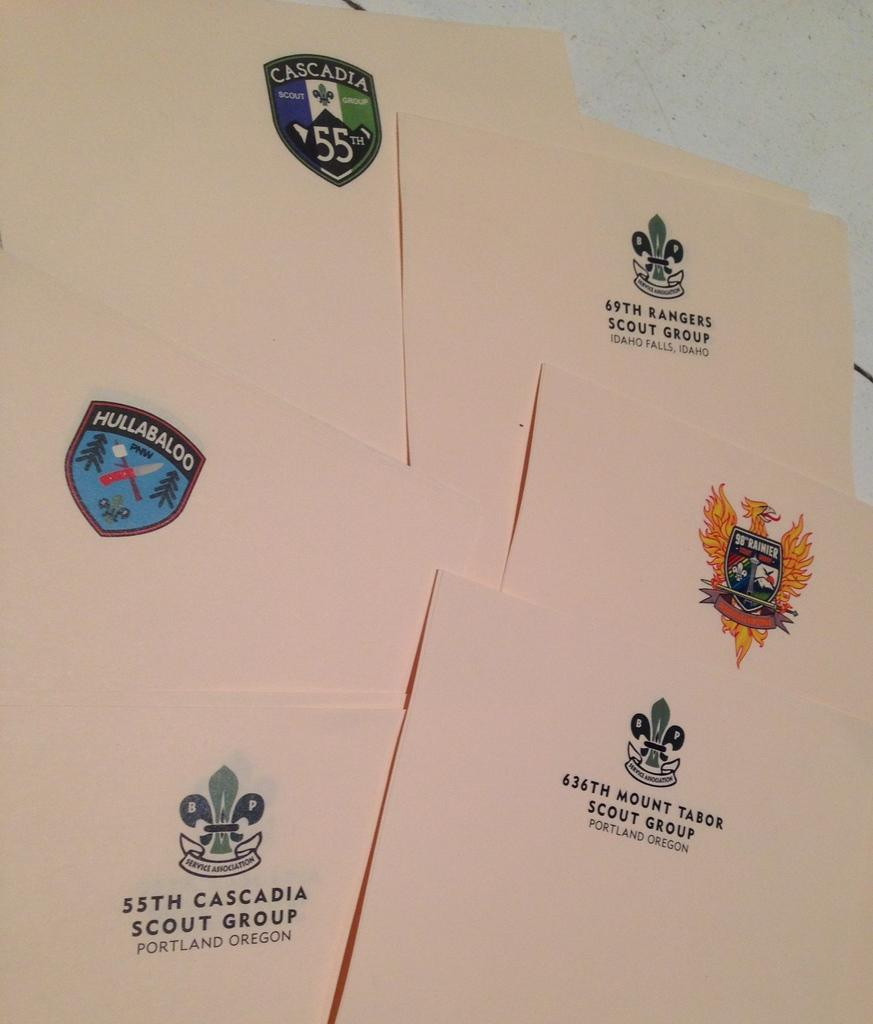<image>
Summarize the visual content of the image. A logo for 636th Mount Tabor Scout Group is on a piece of plain white paper 